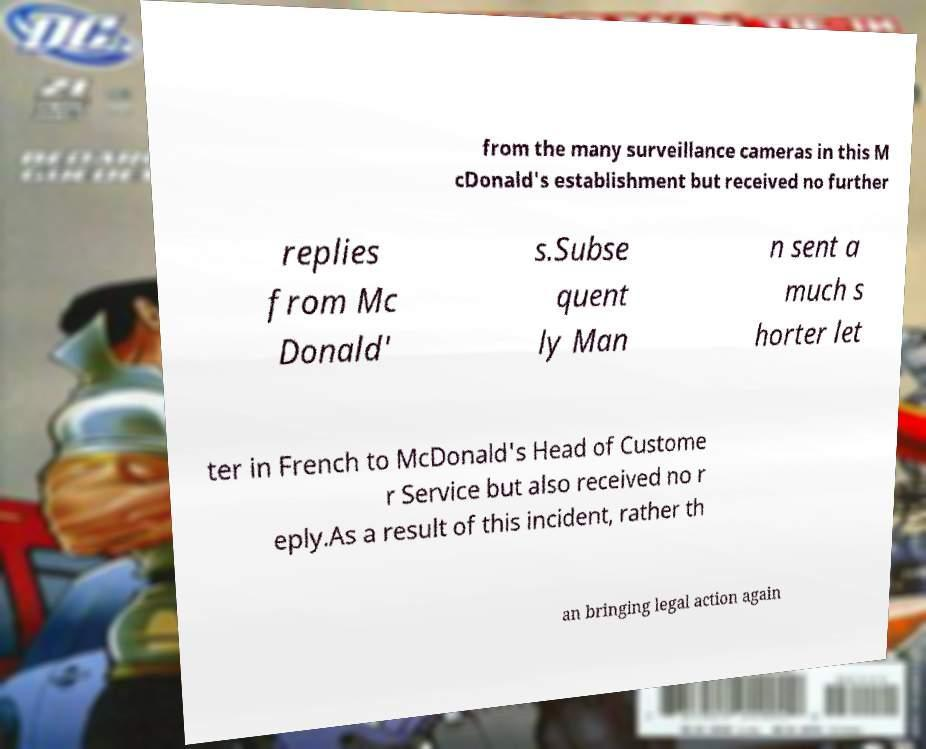Please read and relay the text visible in this image. What does it say? from the many surveillance cameras in this M cDonald's establishment but received no further replies from Mc Donald' s.Subse quent ly Man n sent a much s horter let ter in French to McDonald's Head of Custome r Service but also received no r eply.As a result of this incident, rather th an bringing legal action again 